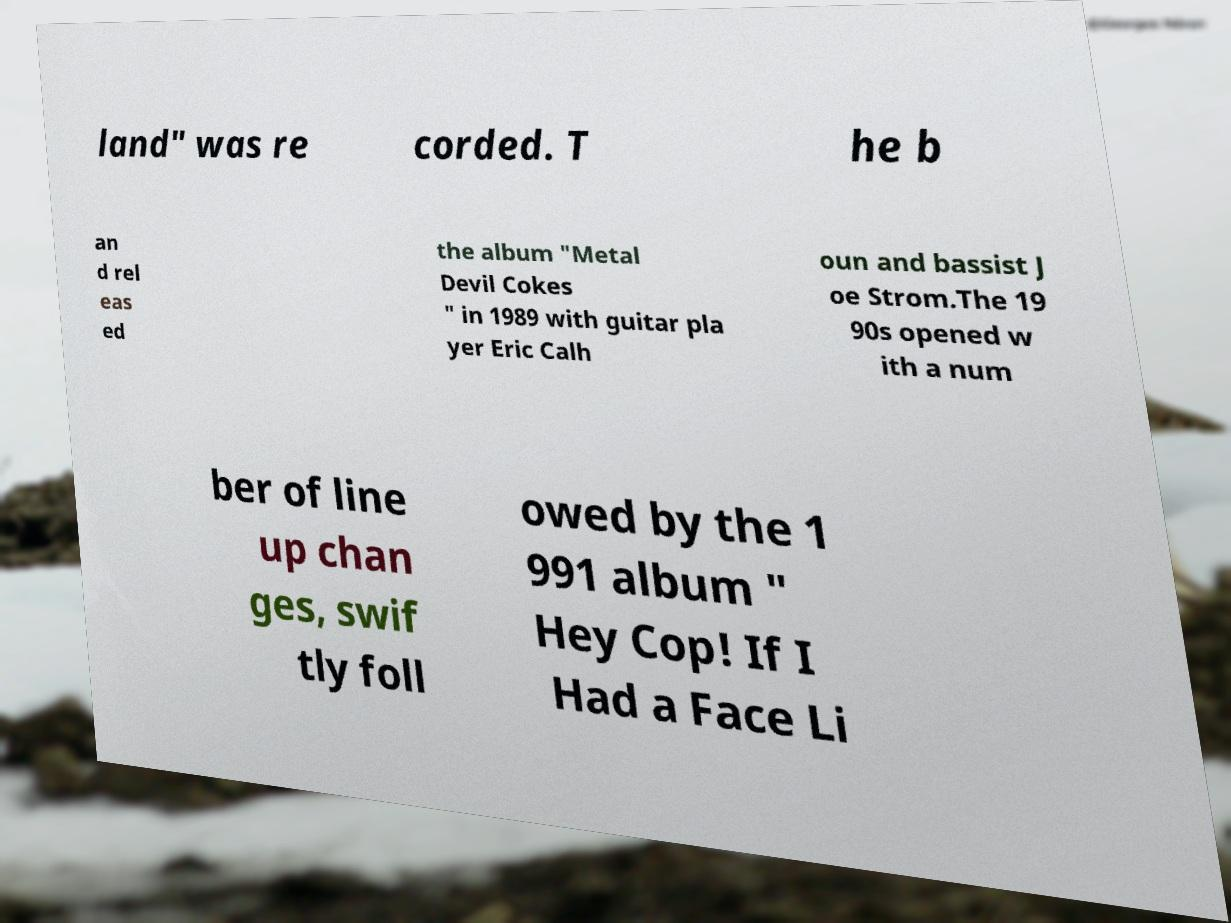Please read and relay the text visible in this image. What does it say? land" was re corded. T he b an d rel eas ed the album "Metal Devil Cokes " in 1989 with guitar pla yer Eric Calh oun and bassist J oe Strom.The 19 90s opened w ith a num ber of line up chan ges, swif tly foll owed by the 1 991 album " Hey Cop! If I Had a Face Li 